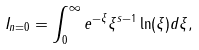<formula> <loc_0><loc_0><loc_500><loc_500>I _ { n = 0 } = \int _ { 0 } ^ { \infty } e ^ { - \xi } { \xi } ^ { s - 1 } \ln ( \xi ) d \xi ,</formula> 